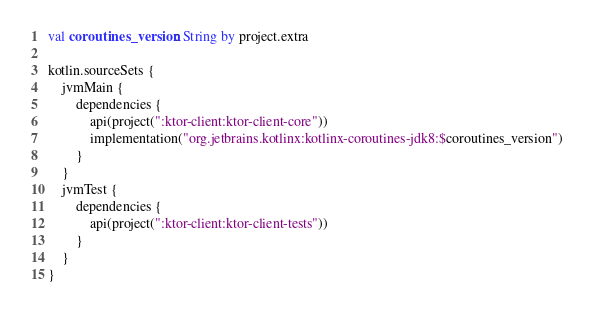Convert code to text. <code><loc_0><loc_0><loc_500><loc_500><_Kotlin_>val coroutines_version: String by project.extra

kotlin.sourceSets {
    jvmMain {
        dependencies {
            api(project(":ktor-client:ktor-client-core"))
            implementation("org.jetbrains.kotlinx:kotlinx-coroutines-jdk8:$coroutines_version")
        }
    }
    jvmTest {
        dependencies {
            api(project(":ktor-client:ktor-client-tests"))
        }
    }
}
</code> 